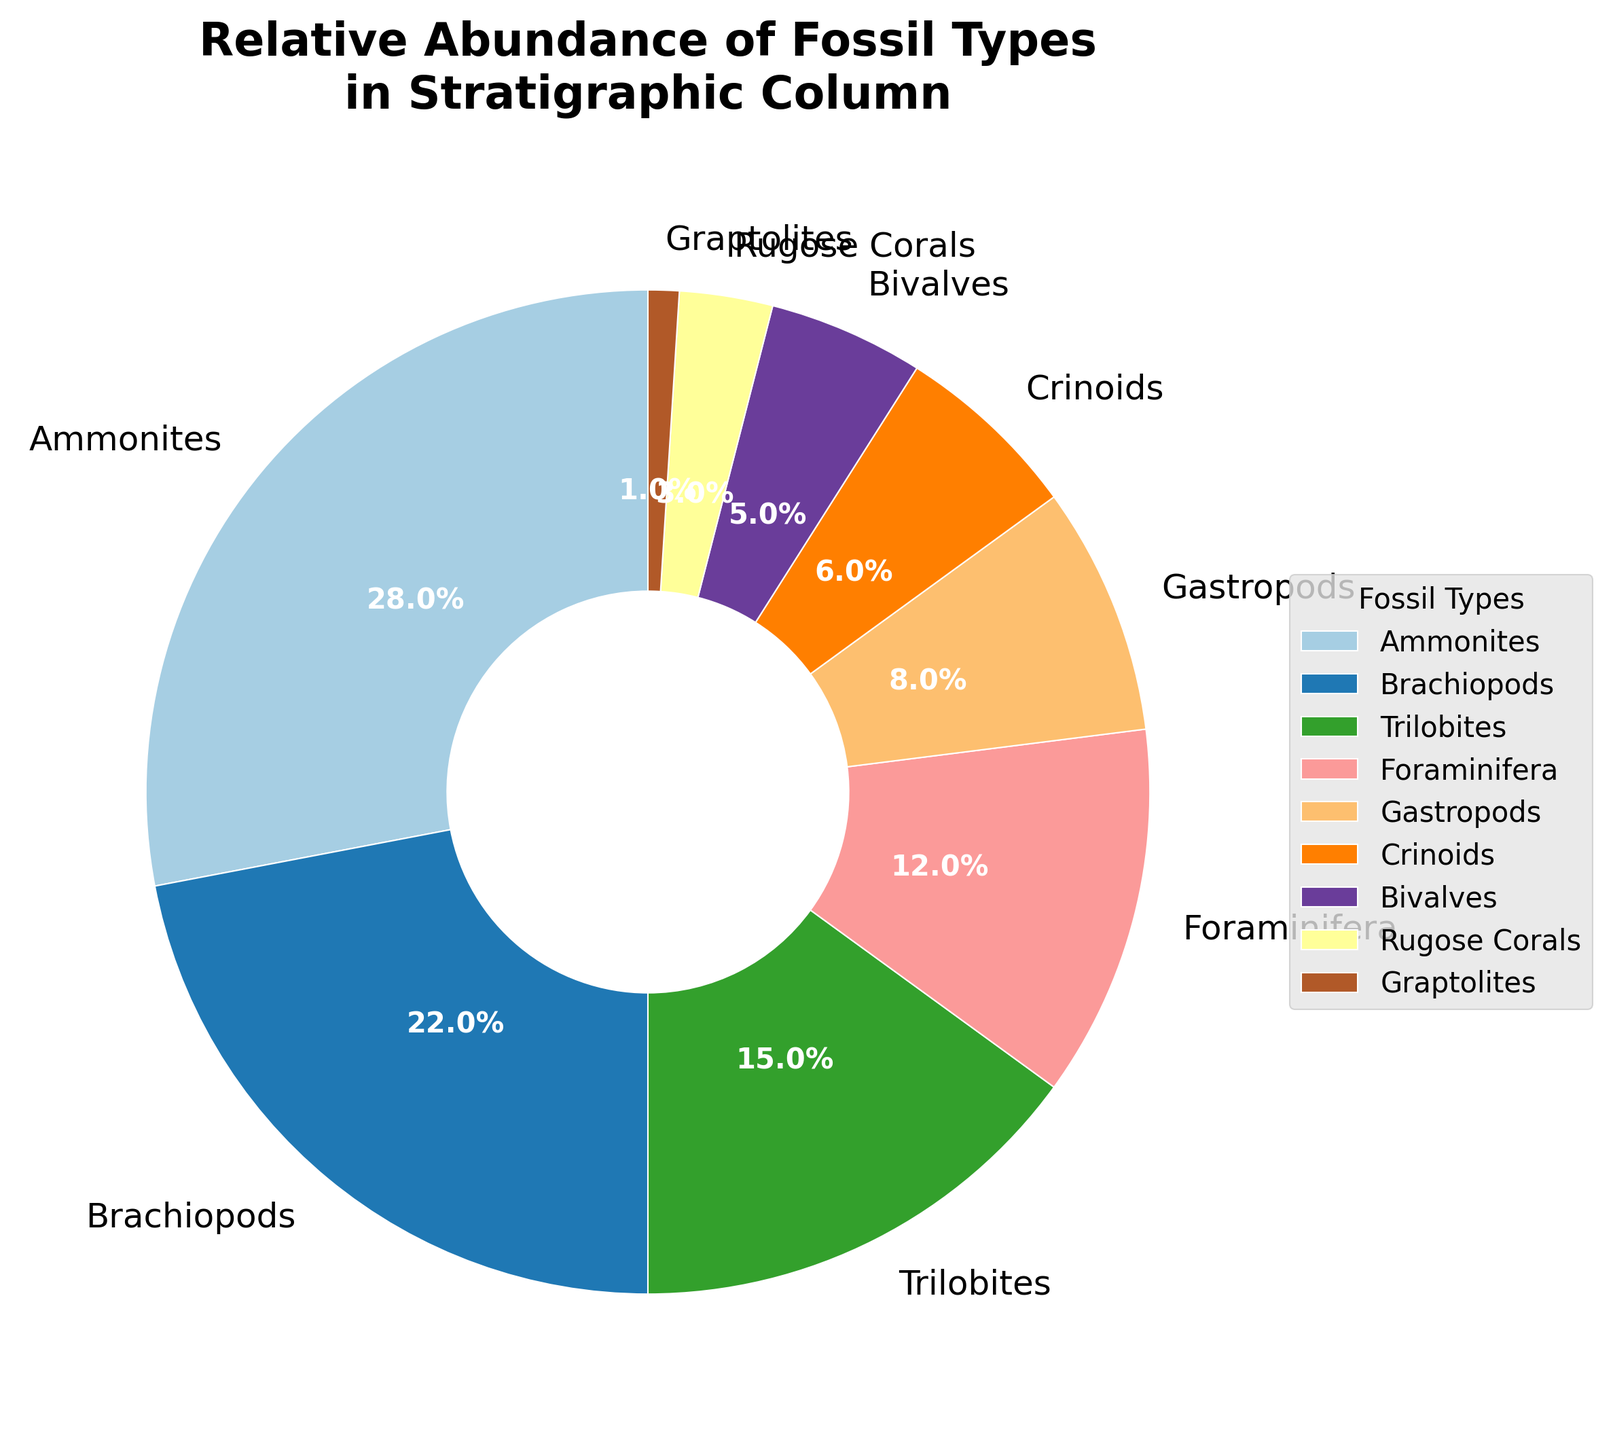What is the most abundant fossil type in the stratigraphic column? The pie chart shows the relative abundances of different fossil types. The largest section represents Ammonites, which is 28%.
Answer: Ammonites Which fossil type has a relative abundance closest to 10%? By examining the pie chart, Foraminifera (12%) has a relative abundance closest to 10%.
Answer: Foraminifera What is the combined relative abundance of Brachiopods and Trilobites? Brachiopods have a 22% abundance, and Trilobites have a 15% abundance. Adding these together gives 22% + 15% = 37%.
Answer: 37% Which fossil types have a smaller relative abundance than Gastropods? The pie chart shows Gastropods at 8%. Fossil types with smaller abundances are Crinoids (6%), Bivalves (5%), Rugose Corals (3%), and Graptolites (1%).
Answer: Crinoids, Bivalves, Rugose Corals, Graptolites How does the relative abundance of Ammonites compare to the combined relative abundance of Crinoids and Bivalves? Ammonites have a 28% abundance. Crinoids and Bivalves together have 6% + 5% = 11%. Comparing these, 28% is greater than 11%.
Answer: Ammonites are more abundant What is the average relative abundance of Crinoids, Bivalves, Rugose Corals, and Graptolites? Adding the abundances: Crinoids (6%) + Bivalves (5%) + Rugose Corals (3%) + Graptolites (1%) = 15%. Dividing by 4 gives 15% / 4 = 3.75%.
Answer: 3.75% Which fossil type forms the smallest segment of the pie chart? The pie chart shows that Graptolites have the smallest segment at 1%.
Answer: Graptolites How many fossil types have a relative abundance greater than 10%? Examining the chart, the fossil types with abundances greater than 10% are Ammonites (28%), Brachiopods (22%), Trilobites (15%), and Foraminifera (12%). There are 4 types in total.
Answer: 4 